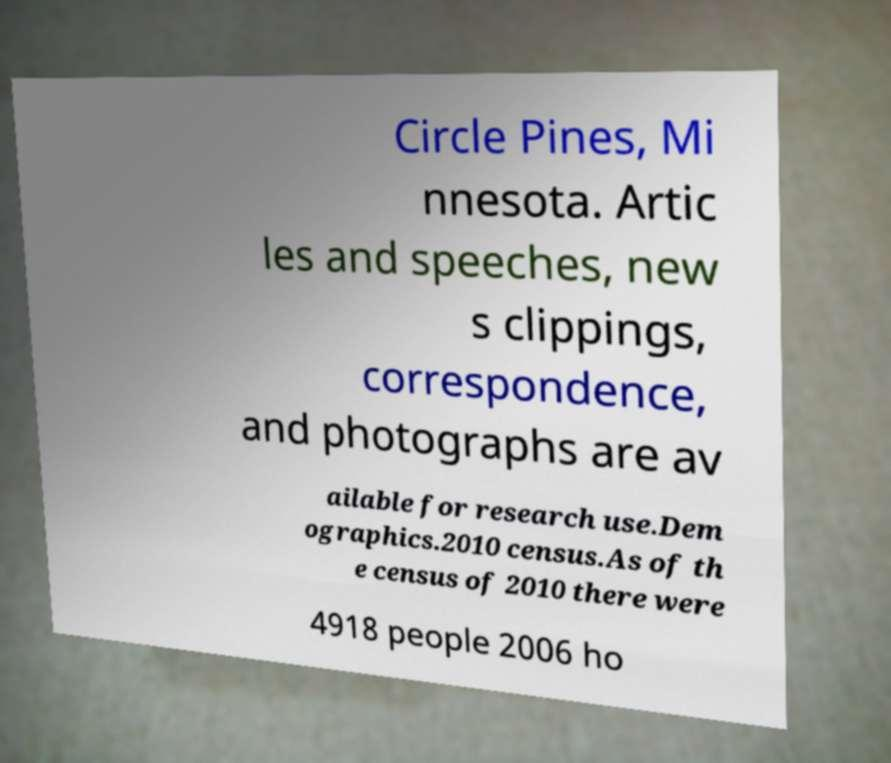What messages or text are displayed in this image? I need them in a readable, typed format. Circle Pines, Mi nnesota. Artic les and speeches, new s clippings, correspondence, and photographs are av ailable for research use.Dem ographics.2010 census.As of th e census of 2010 there were 4918 people 2006 ho 